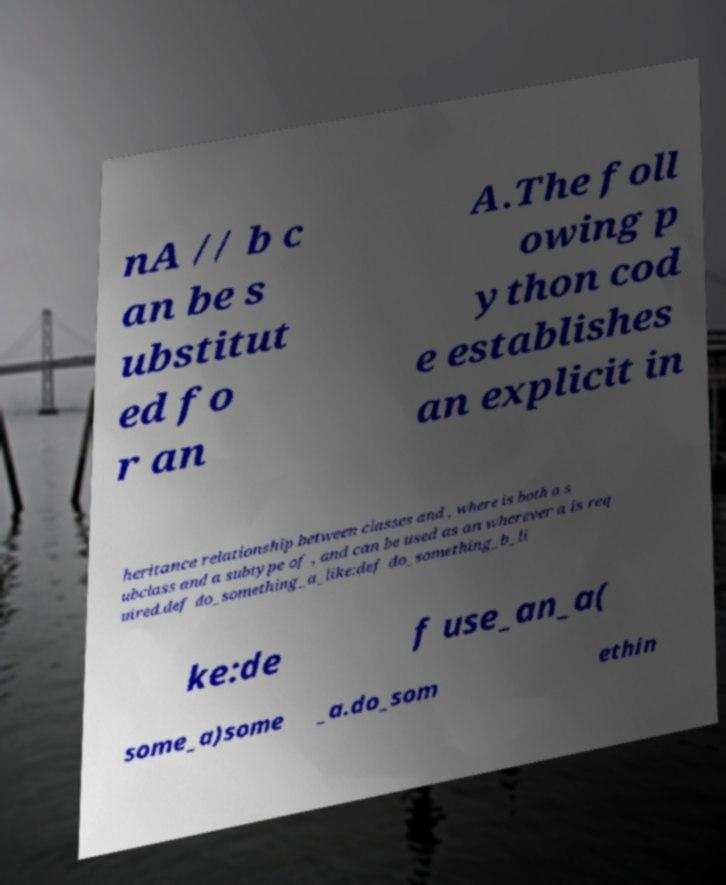Could you extract and type out the text from this image? nA // b c an be s ubstitut ed fo r an A.The foll owing p ython cod e establishes an explicit in heritance relationship between classes and , where is both a s ubclass and a subtype of , and can be used as an wherever a is req uired.def do_something_a_like:def do_something_b_li ke:de f use_an_a( some_a)some _a.do_som ethin 